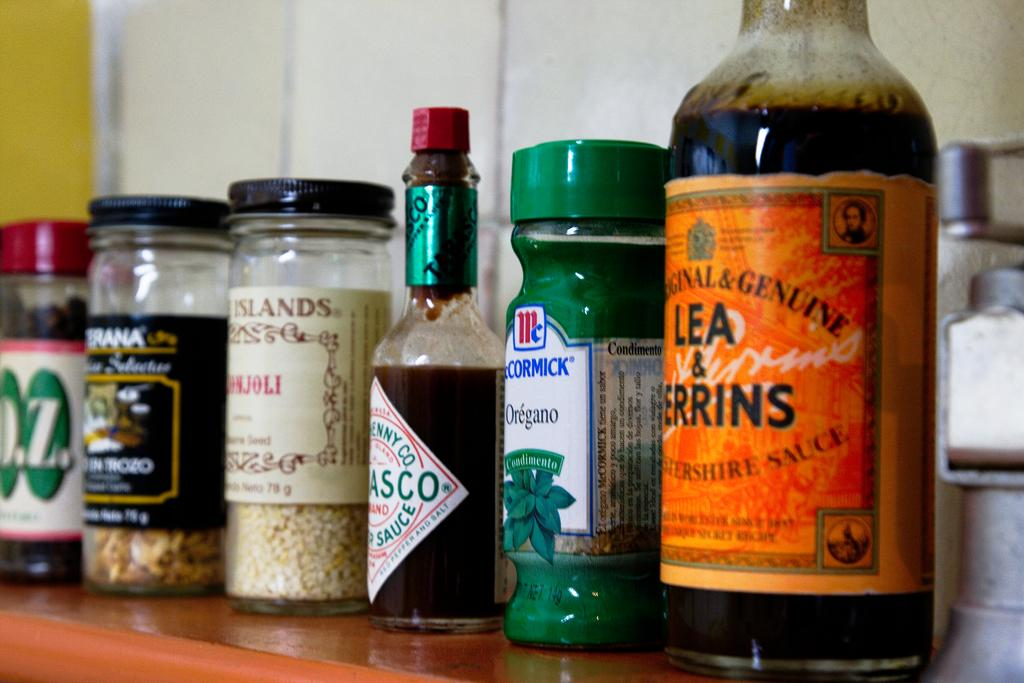<image>
Share a concise interpretation of the image provided. Various bottles of seasonings, such as Tabasco sauce lined up on a shelf. 